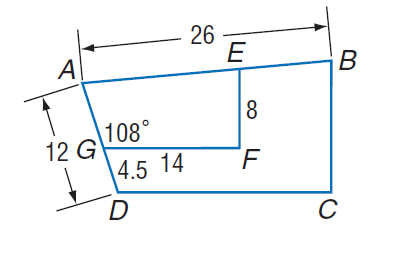Answer the mathemtical geometry problem and directly provide the correct option letter.
Question: Polygon A B C D \sim polygon A E F G, m \angle A G F = 108, G F = 14, A D = 12, D G = 4.5, E F = 8, and A B = 26. Find the perimeter of trapezoid A B C D.
Choices: A: 12 B: 52 C: 73.2 D: 100 C 